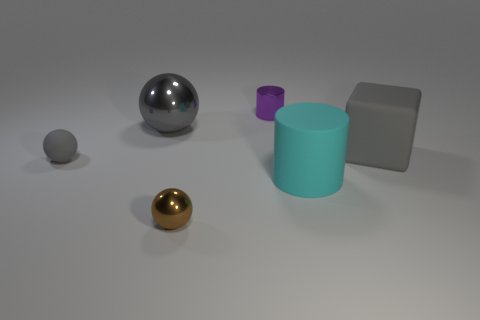Subtract 1 cylinders. How many cylinders are left? 1 Add 3 gray objects. How many gray objects exist? 6 Add 1 blocks. How many objects exist? 7 Subtract all gray spheres. How many spheres are left? 1 Subtract all gray balls. How many balls are left? 1 Subtract 0 blue blocks. How many objects are left? 6 Subtract all cubes. How many objects are left? 5 Subtract all blue spheres. Subtract all purple cylinders. How many spheres are left? 3 Subtract all yellow balls. How many green cubes are left? 0 Subtract all big green metal spheres. Subtract all big matte objects. How many objects are left? 4 